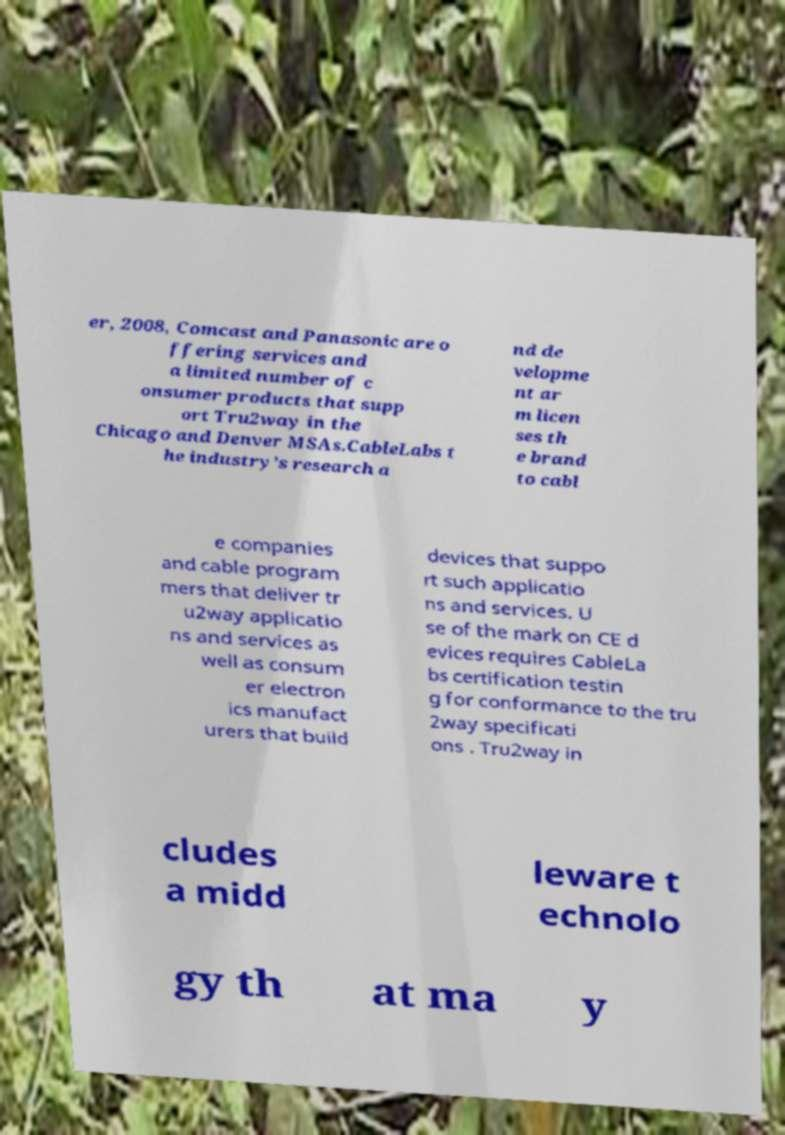Can you accurately transcribe the text from the provided image for me? er, 2008, Comcast and Panasonic are o ffering services and a limited number of c onsumer products that supp ort Tru2way in the Chicago and Denver MSAs.CableLabs t he industry’s research a nd de velopme nt ar m licen ses th e brand to cabl e companies and cable program mers that deliver tr u2way applicatio ns and services as well as consum er electron ics manufact urers that build devices that suppo rt such applicatio ns and services. U se of the mark on CE d evices requires CableLa bs certification testin g for conformance to the tru 2way specificati ons . Tru2way in cludes a midd leware t echnolo gy th at ma y 